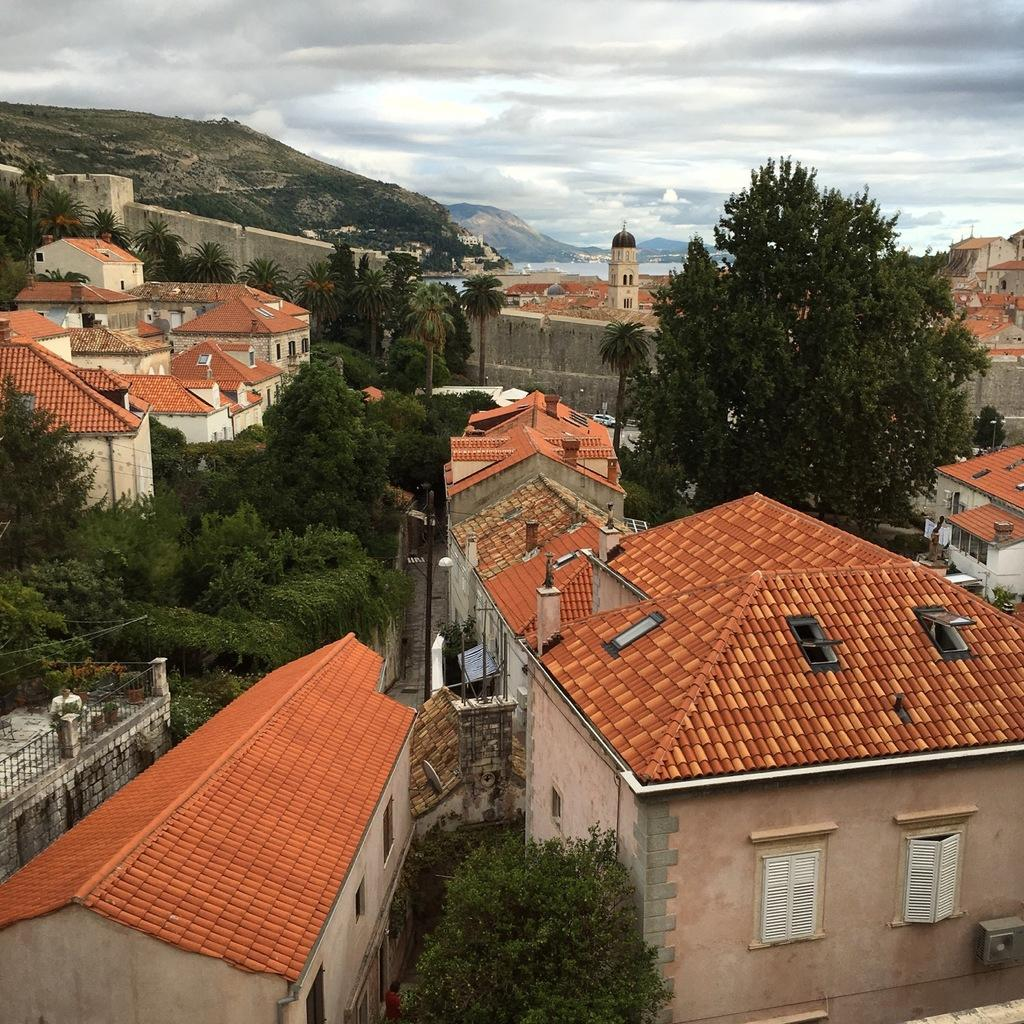What type of structures can be seen in the image? There are houses in the image. What natural elements are present in the image? There are trees and mountains in the image. What is the condition of the sky in the image? The sky is cloudy in the image. What type of bead is used to decorate the houses in the image? There is no mention of beads or any decorative elements on the houses in the image. What story is being told by the trees in the image? The trees in the image are not telling a story; they are simply part of the natural landscape. 